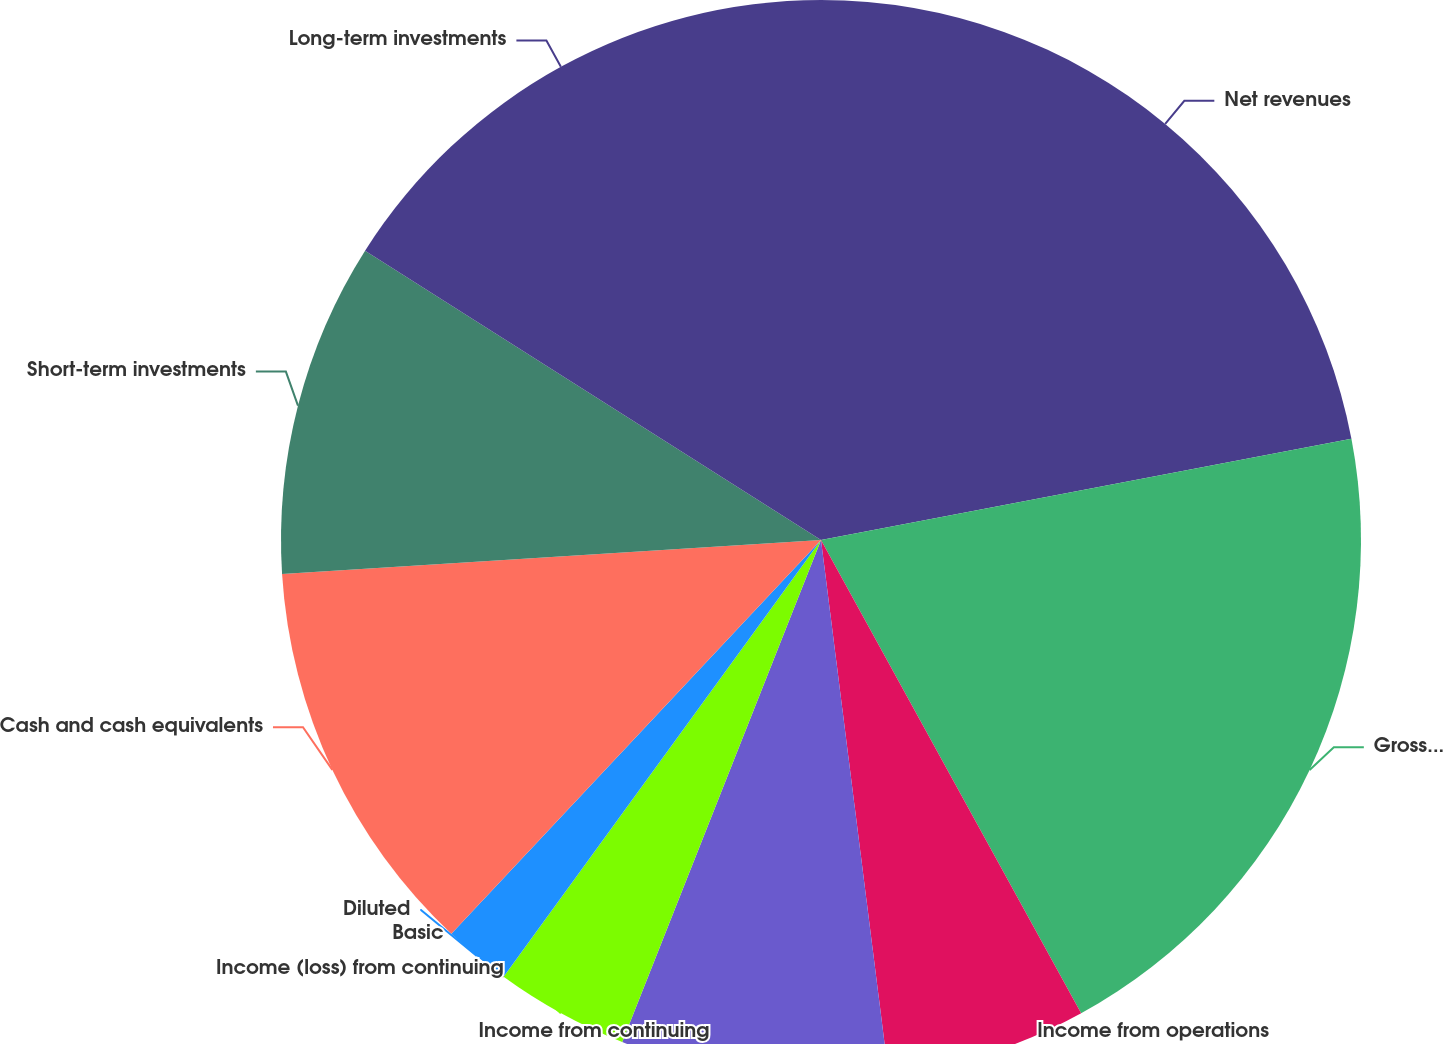Convert chart to OTSL. <chart><loc_0><loc_0><loc_500><loc_500><pie_chart><fcel>Net revenues<fcel>Gross profit<fcel>Income from operations<fcel>Income from continuing<fcel>Income (loss) from continuing<fcel>Basic<fcel>Diluted<fcel>Cash and cash equivalents<fcel>Short-term investments<fcel>Long-term investments<nl><fcel>22.0%<fcel>20.0%<fcel>6.0%<fcel>8.0%<fcel>4.0%<fcel>0.0%<fcel>2.0%<fcel>12.0%<fcel>10.0%<fcel>16.0%<nl></chart> 